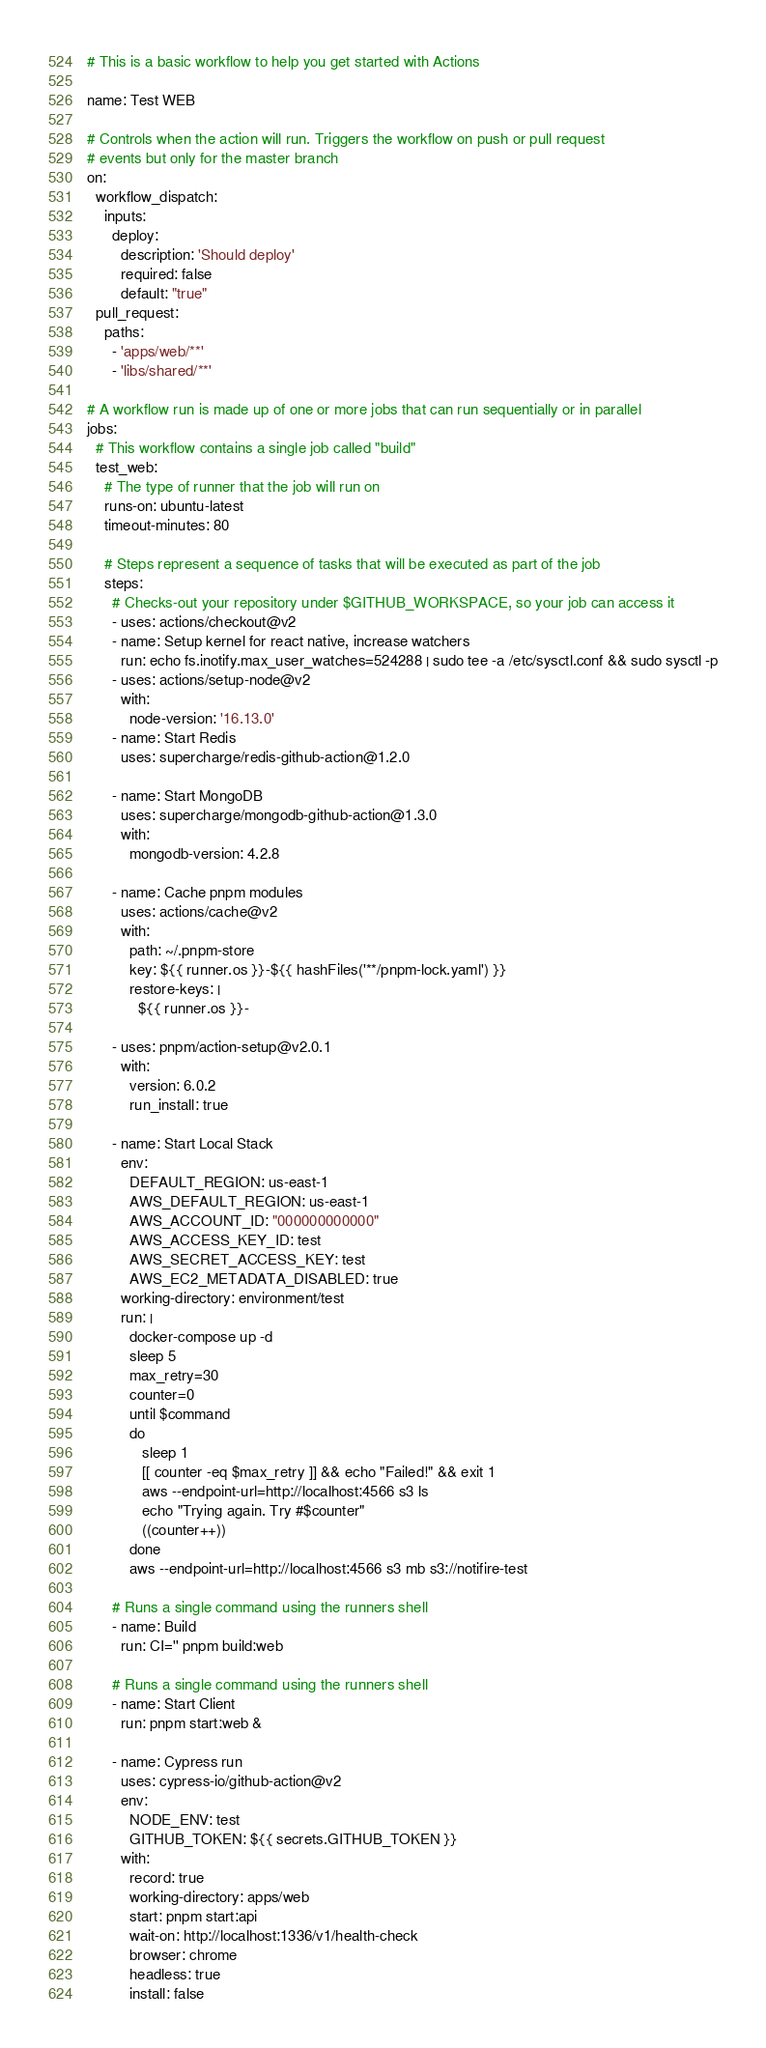Convert code to text. <code><loc_0><loc_0><loc_500><loc_500><_YAML_># This is a basic workflow to help you get started with Actions

name: Test WEB

# Controls when the action will run. Triggers the workflow on push or pull request
# events but only for the master branch
on:
  workflow_dispatch:
    inputs:
      deploy:
        description: 'Should deploy'
        required: false
        default: "true"
  pull_request:
    paths:
      - 'apps/web/**'
      - 'libs/shared/**'

# A workflow run is made up of one or more jobs that can run sequentially or in parallel
jobs:
  # This workflow contains a single job called "build"
  test_web:
    # The type of runner that the job will run on
    runs-on: ubuntu-latest
    timeout-minutes: 80

    # Steps represent a sequence of tasks that will be executed as part of the job
    steps:
      # Checks-out your repository under $GITHUB_WORKSPACE, so your job can access it
      - uses: actions/checkout@v2
      - name: Setup kernel for react native, increase watchers
        run: echo fs.inotify.max_user_watches=524288 | sudo tee -a /etc/sysctl.conf && sudo sysctl -p
      - uses: actions/setup-node@v2
        with:
          node-version: '16.13.0'
      - name: Start Redis
        uses: supercharge/redis-github-action@1.2.0

      - name: Start MongoDB
        uses: supercharge/mongodb-github-action@1.3.0
        with:
          mongodb-version: 4.2.8

      - name: Cache pnpm modules
        uses: actions/cache@v2
        with:
          path: ~/.pnpm-store
          key: ${{ runner.os }}-${{ hashFiles('**/pnpm-lock.yaml') }}
          restore-keys: |
            ${{ runner.os }}-

      - uses: pnpm/action-setup@v2.0.1
        with:
          version: 6.0.2
          run_install: true

      - name: Start Local Stack
        env:
          DEFAULT_REGION: us-east-1
          AWS_DEFAULT_REGION: us-east-1
          AWS_ACCOUNT_ID: "000000000000"
          AWS_ACCESS_KEY_ID: test
          AWS_SECRET_ACCESS_KEY: test
          AWS_EC2_METADATA_DISABLED: true
        working-directory: environment/test
        run: |
          docker-compose up -d
          sleep 5
          max_retry=30
          counter=0
          until $command
          do
             sleep 1
             [[ counter -eq $max_retry ]] && echo "Failed!" && exit 1
             aws --endpoint-url=http://localhost:4566 s3 ls
             echo "Trying again. Try #$counter"
             ((counter++))
          done
          aws --endpoint-url=http://localhost:4566 s3 mb s3://notifire-test

      # Runs a single command using the runners shell
      - name: Build
        run: CI='' pnpm build:web

      # Runs a single command using the runners shell
      - name: Start Client
        run: pnpm start:web &

      - name: Cypress run
        uses: cypress-io/github-action@v2
        env:
          NODE_ENV: test
          GITHUB_TOKEN: ${{ secrets.GITHUB_TOKEN }}
        with:
          record: true
          working-directory: apps/web
          start: pnpm start:api
          wait-on: http://localhost:1336/v1/health-check
          browser: chrome
          headless: true
          install: false
</code> 